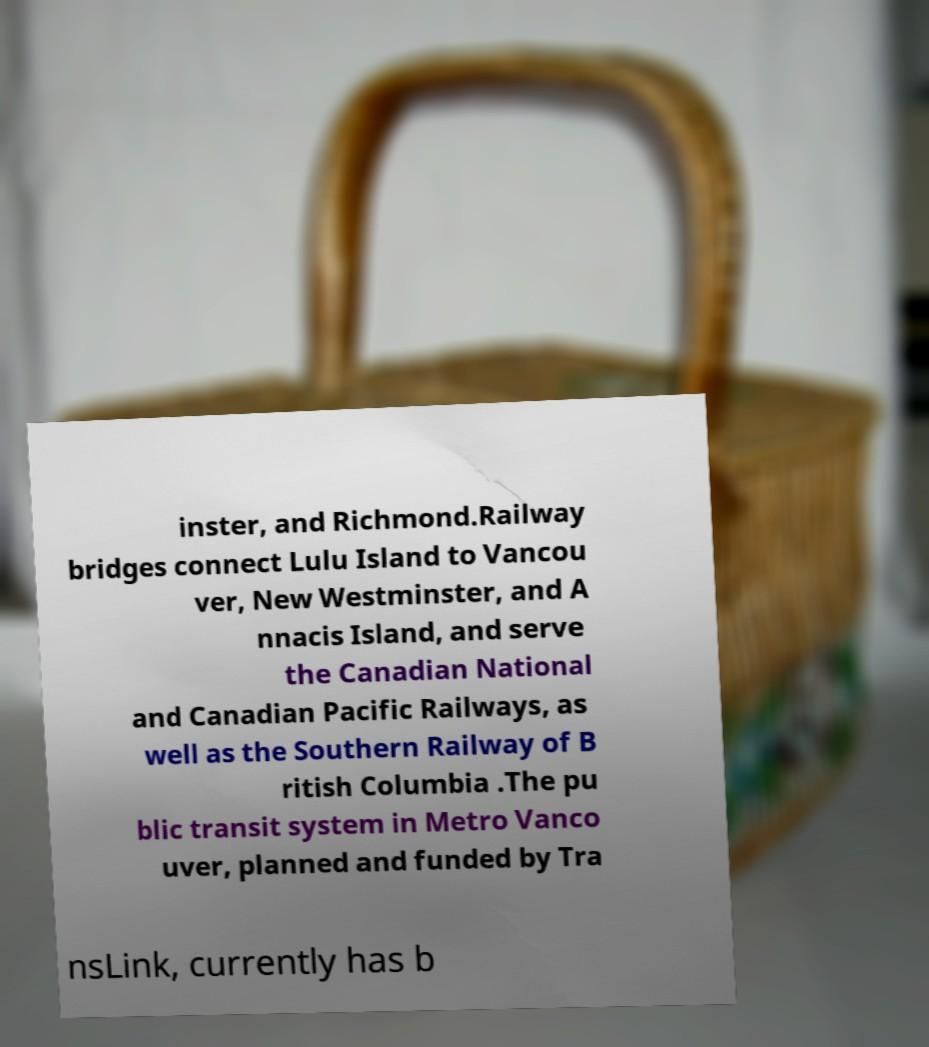Please read and relay the text visible in this image. What does it say? inster, and Richmond.Railway bridges connect Lulu Island to Vancou ver, New Westminster, and A nnacis Island, and serve the Canadian National and Canadian Pacific Railways, as well as the Southern Railway of B ritish Columbia .The pu blic transit system in Metro Vanco uver, planned and funded by Tra nsLink, currently has b 